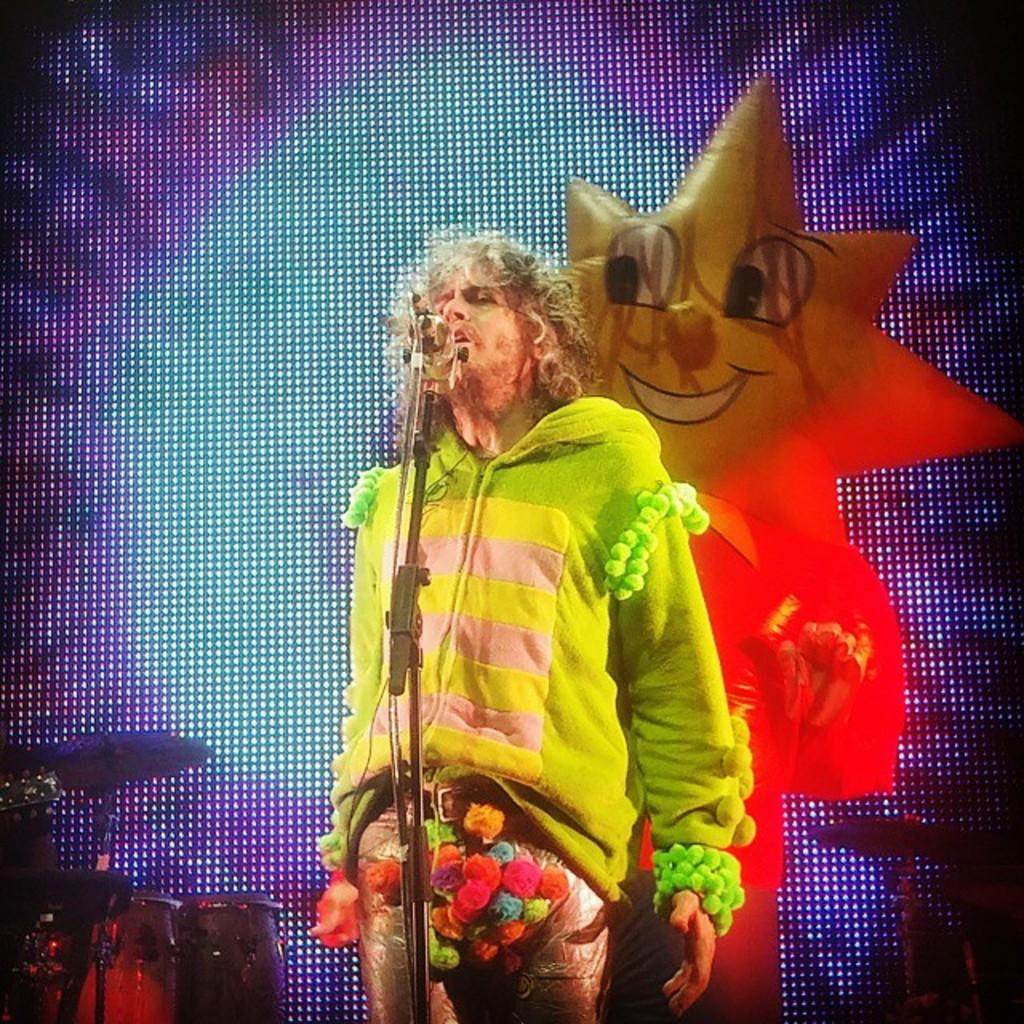What is the main subject of the image? There is a man standing in the image. What object is present near the man? There is a mic with a stand in the image. What else can be seen in the image related to music? There are musical instruments in the image. What is displayed on the screen in the image? There is a picture on a screen in the image. What type of hat is the man wearing in the image? The man is not wearing a hat in the image. Can you tell me how many people are joining the man in the image? There is no indication of additional people joining the man in the image. 